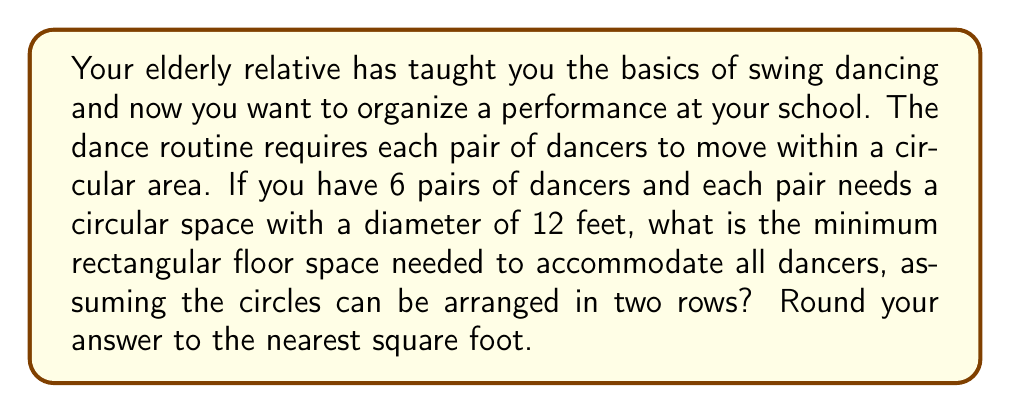What is the answer to this math problem? Let's approach this step-by-step:

1) First, we need to calculate the radius of each circular space:
   $$r = \frac{diameter}{2} = \frac{12}{2} = 6\text{ feet}$$

2) We need to fit 6 circles, so we can arrange them in 2 rows of 3 circles each.

3) For the width of the rectangle:
   - We need 3 diameters in a row
   $$width = 3 * 12 = 36\text{ feet}$$

4) For the height of the rectangle:
   - We need 2 diameters in a column
   $$height = 2 * 12 = 24\text{ feet}$$

5) However, we can optimize this space by allowing the circles to touch. In this arrangement, the centers of the circles will form a rectangle.

6) The width of this optimized rectangle will be:
   $$width_{opt} = 2r + 2r + 2r = 6r = 6 * 6 = 36\text{ feet}$$

7) The height of this optimized rectangle will be:
   $$height_{opt} = 2r + 2r = 4r = 4 * 6 = 24\text{ feet}$$

8) The total floor space is then:
   $$area = width_{opt} * height_{opt} = 36 * 24 = 864\text{ square feet}$$

9) As we were asked to round to the nearest square foot, our final answer is 864 square feet.

[asy]
unitsize(5mm);
for(int i=0; i<3; ++i) {
  for(int j=0; j<2; ++j) {
    draw(circle((2*i,2*j),1));
  }
}
draw(box((0,0),(6,4)), blue);
label("36 ft", (3,-0.5));
label("24 ft", (6.5,2), E);
[/asy]
Answer: 864 square feet 